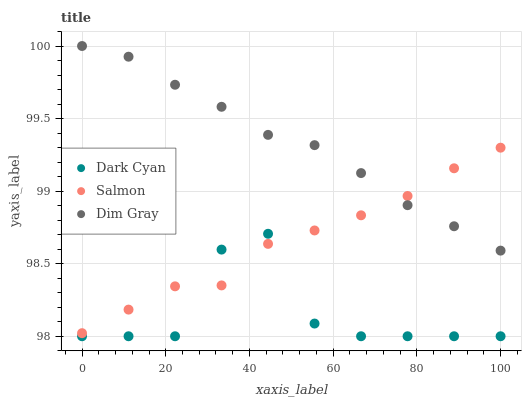Does Dark Cyan have the minimum area under the curve?
Answer yes or no. Yes. Does Dim Gray have the maximum area under the curve?
Answer yes or no. Yes. Does Salmon have the minimum area under the curve?
Answer yes or no. No. Does Salmon have the maximum area under the curve?
Answer yes or no. No. Is Dim Gray the smoothest?
Answer yes or no. Yes. Is Dark Cyan the roughest?
Answer yes or no. Yes. Is Salmon the smoothest?
Answer yes or no. No. Is Salmon the roughest?
Answer yes or no. No. Does Dark Cyan have the lowest value?
Answer yes or no. Yes. Does Salmon have the lowest value?
Answer yes or no. No. Does Dim Gray have the highest value?
Answer yes or no. Yes. Does Salmon have the highest value?
Answer yes or no. No. Is Dark Cyan less than Dim Gray?
Answer yes or no. Yes. Is Dim Gray greater than Dark Cyan?
Answer yes or no. Yes. Does Salmon intersect Dim Gray?
Answer yes or no. Yes. Is Salmon less than Dim Gray?
Answer yes or no. No. Is Salmon greater than Dim Gray?
Answer yes or no. No. Does Dark Cyan intersect Dim Gray?
Answer yes or no. No. 